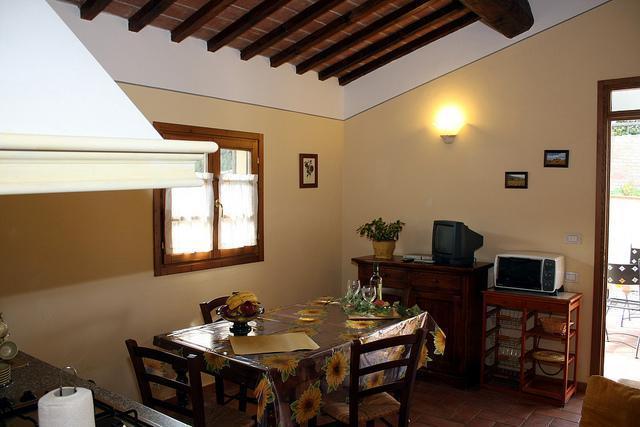How many chairs are in the picture?
Give a very brief answer. 3. How many people are not wearing shirts?
Give a very brief answer. 0. 